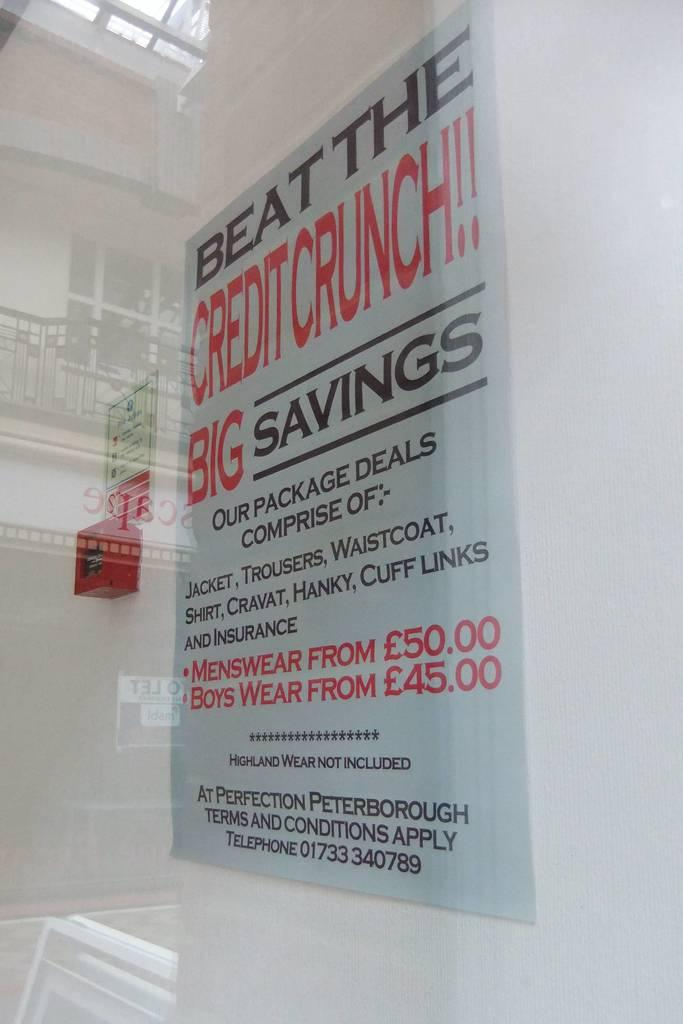<image>
Offer a succinct explanation of the picture presented. A store sign encourages customers to Beat The Credit Crunch and Pick Up Big Savings on menswear and boys wear. 